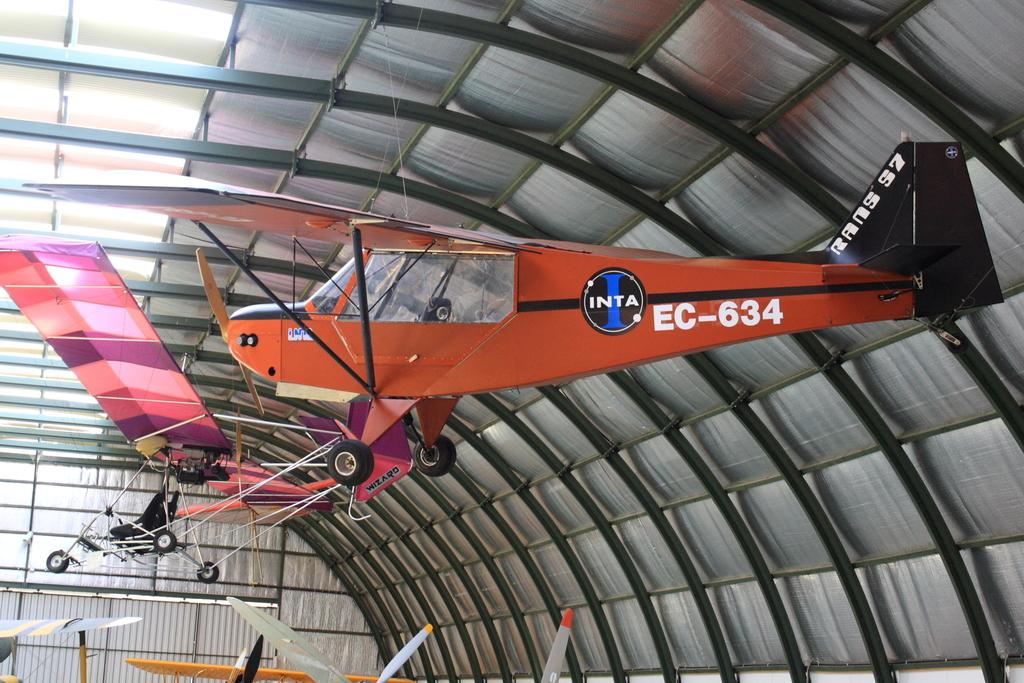<image>
Give a short and clear explanation of the subsequent image. a red plane with the letters ec on the tale 